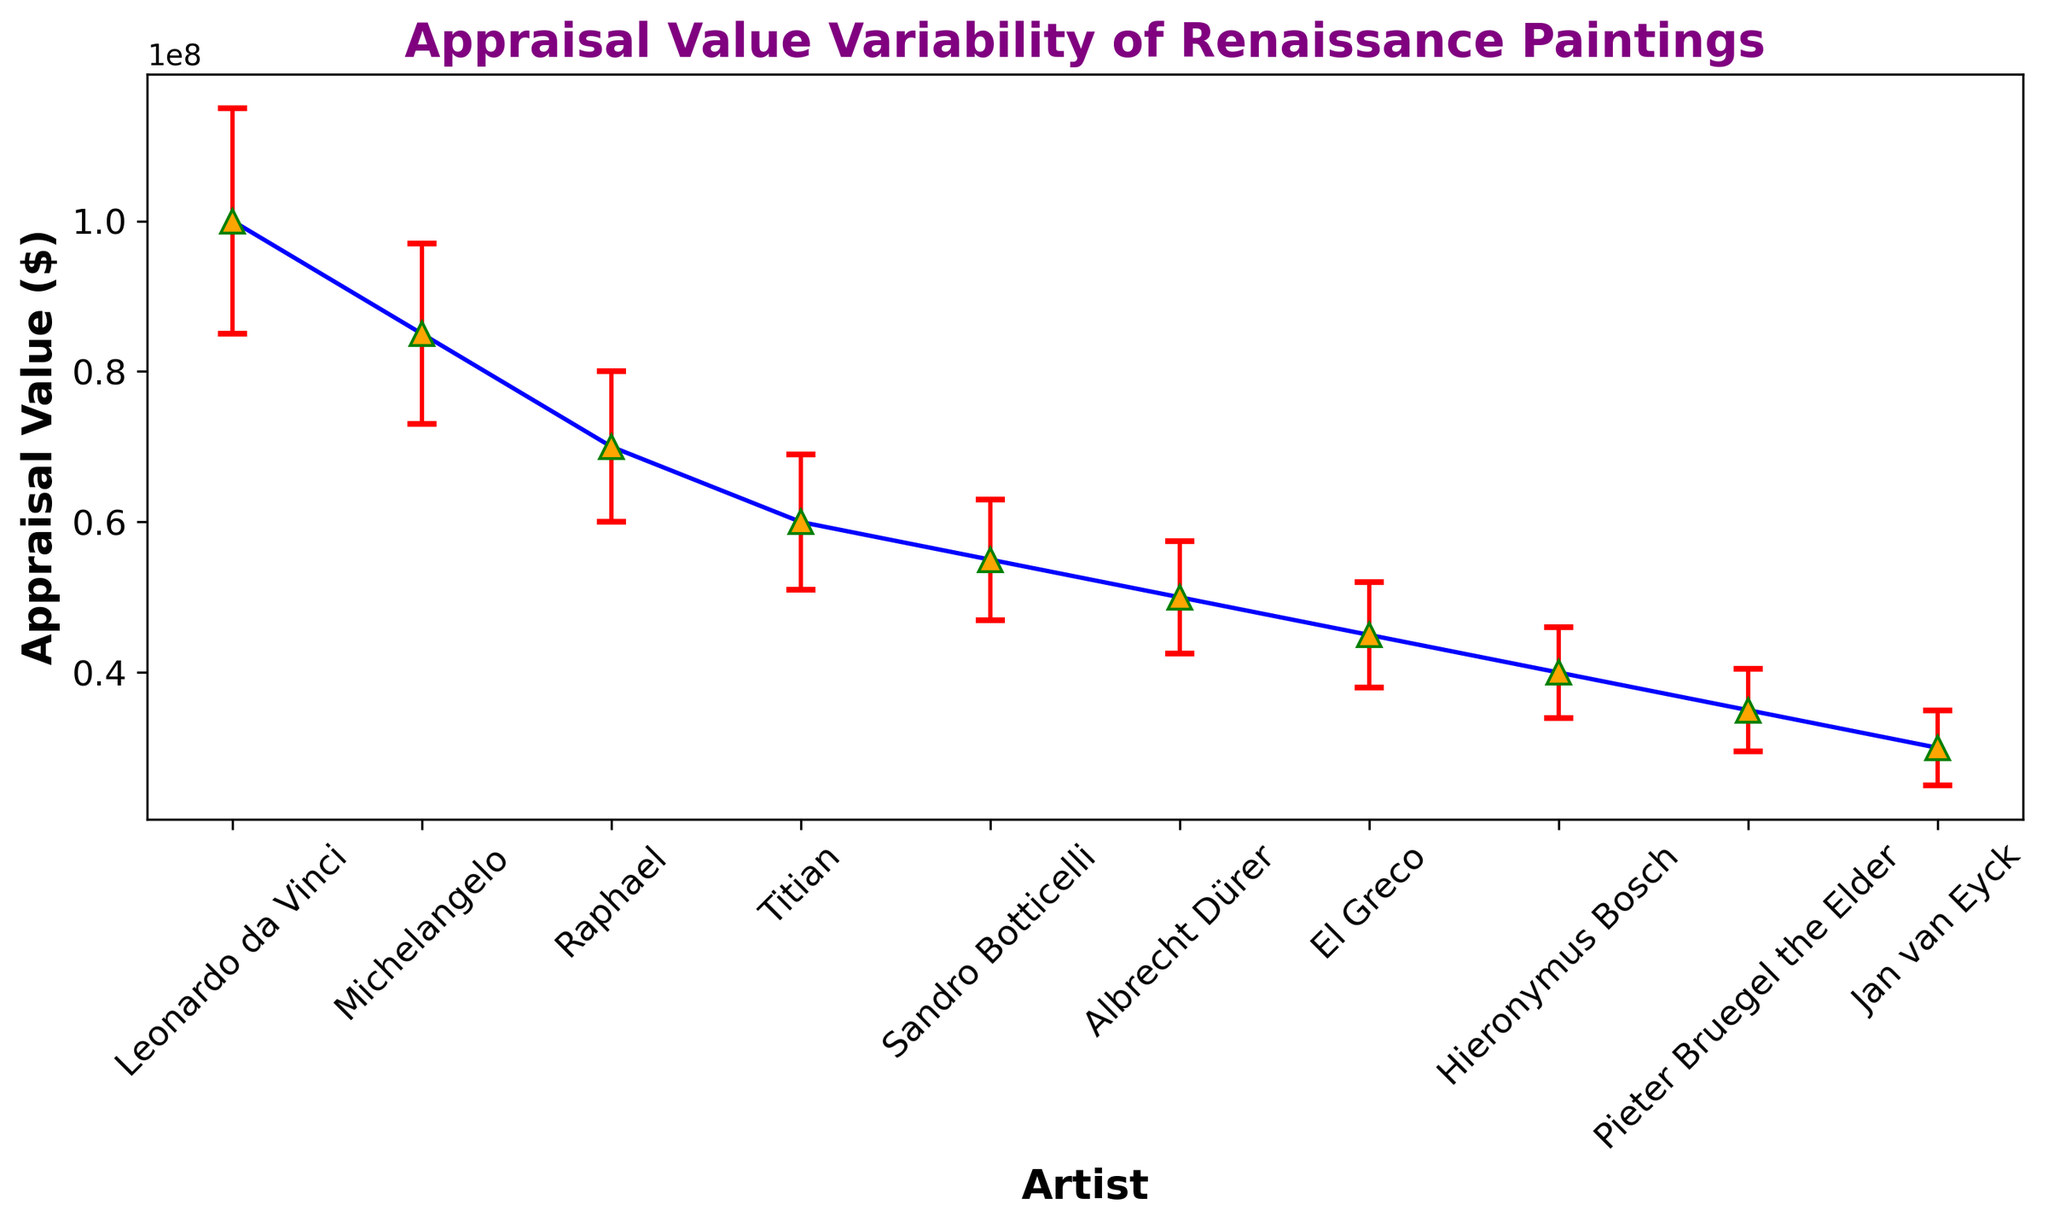Which artist's paintings have the highest appraisal value? The highest appraisal value is represented by the data point with the largest value on the y-axis. In this case, it is Leonardo da Vinci with an appraisal value of $100,000,000.
Answer: Leonardo da Vinci Which artist has the lowest appraisal value? The artist with the lowest appraisal value is represented by the smallest value on the y-axis. Here, it is Jan van Eyck with an appraisal value of $30,000,000.
Answer: Jan van Eyck What is the difference in appraisal value between Michelangelo and Raphael? Michelangelo's appraisal value is $85,000,000, and Raphael's is $70,000,000. The difference is calculated as $85,000,000 - $70,000,000.
Answer: $15,000,000 Which artist has the largest variability in their painting's appraisal value? The variability is indicated by the length of the error bars. The artist with the largest error bar is Leonardo da Vinci with a standard deviation of $15,000,000.
Answer: Leonardo da Vinci Compare the appraisal values of El Greco and Hieronymus Bosch and determine which is higher. El Greco's appraisal value is $45,000,000 while Hieronymus Bosch's appraisal value is $40,000,000. El Greco's appraisal value is higher.
Answer: El Greco Which two artists have appraisal values that are closest to each other? By visually inspecting the y-axis values, Sandro Botticelli with $55,000,000 and Albrecht Dürer with $50,000,000 are the closest.
Answer: Sandro Botticelli and Albrecht Dürer What is the average appraisal value of paintings by Leonardo da Vinci and Michelangelo? The average of Leonardo da Vinci's ($100,000,000) and Michelangelo's ($85,000,000) appraisal values is calculated as ($100,000,000 + $85,000,000) / 2.
Answer: $92,500,000 Compare the standard deviations of the appraisal values of Titian and Sandro Botticelli. Which one has a smaller standard deviation? Titian has a standard deviation of $9,000,000 while Sandro Botticelli has $8,000,000. Therefore, Sandro Botticelli has a smaller standard deviation.
Answer: Sandro Botticelli How much higher is Jan van Eyck’s appraisal value compared to Pieter Bruegel the Elder's? Jan van Eyck’s appraisal value is $30,000,000, and Pieter Bruegel the Elder’s is $35,000,000. The difference is $35,000,000 - $30,000,000.
Answer: $5,000,000 What is the median appraisal value among all the artists? Listing the appraisal values in ascending order: $30,000,000 (Jan van Eyck), $35,000,000 (Pieter Bruegel the Elder), $40,000,000 (Hieronymus Bosch), $45,000,000 (El Greco), $50,000,000 (Albrecht Dürer), $55,000,000 (Sandro Botticelli), $60,000,000 (Titian), $70,000,000 (Raphael), $85,000,000 (Michelangelo), $100,000,000 (Leonardo da Vinci). The median value (middle point of 10 values) is the average of the 5th and 6th values: ($50,000,000 + $55,000,000) / 2.
Answer: $52,500,000 